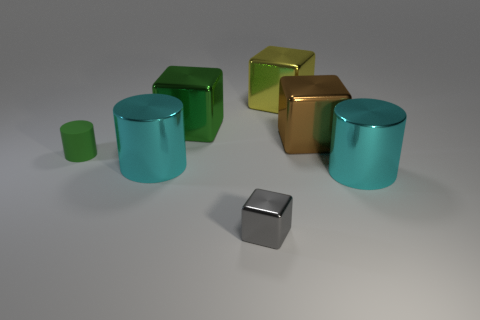Can you tell me what material these objects seem to be made of? Based on the image, all objects have a reflective surface with a smooth texture, suggesting they could be made of a polished metal or a similar synthetic material with a metallic finish. 